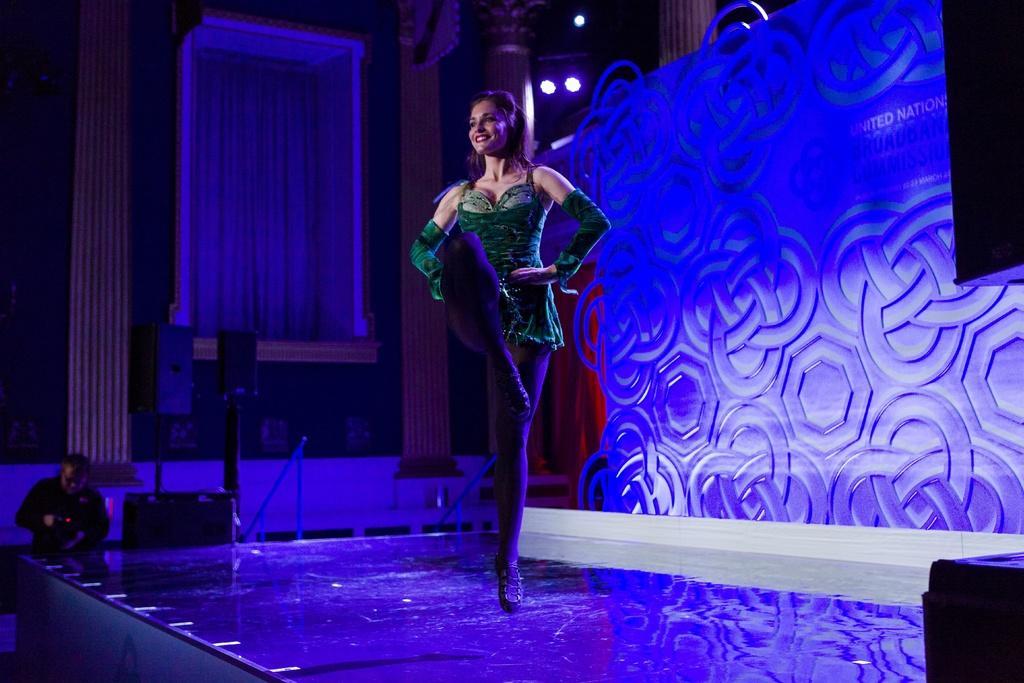Can you describe this image briefly? In this image I can see the person standing and wearing the green color dress and the person is smiling. To the left I can see one more person and the sound boxes can be seen. In the back I can see the curtain and the lights. 